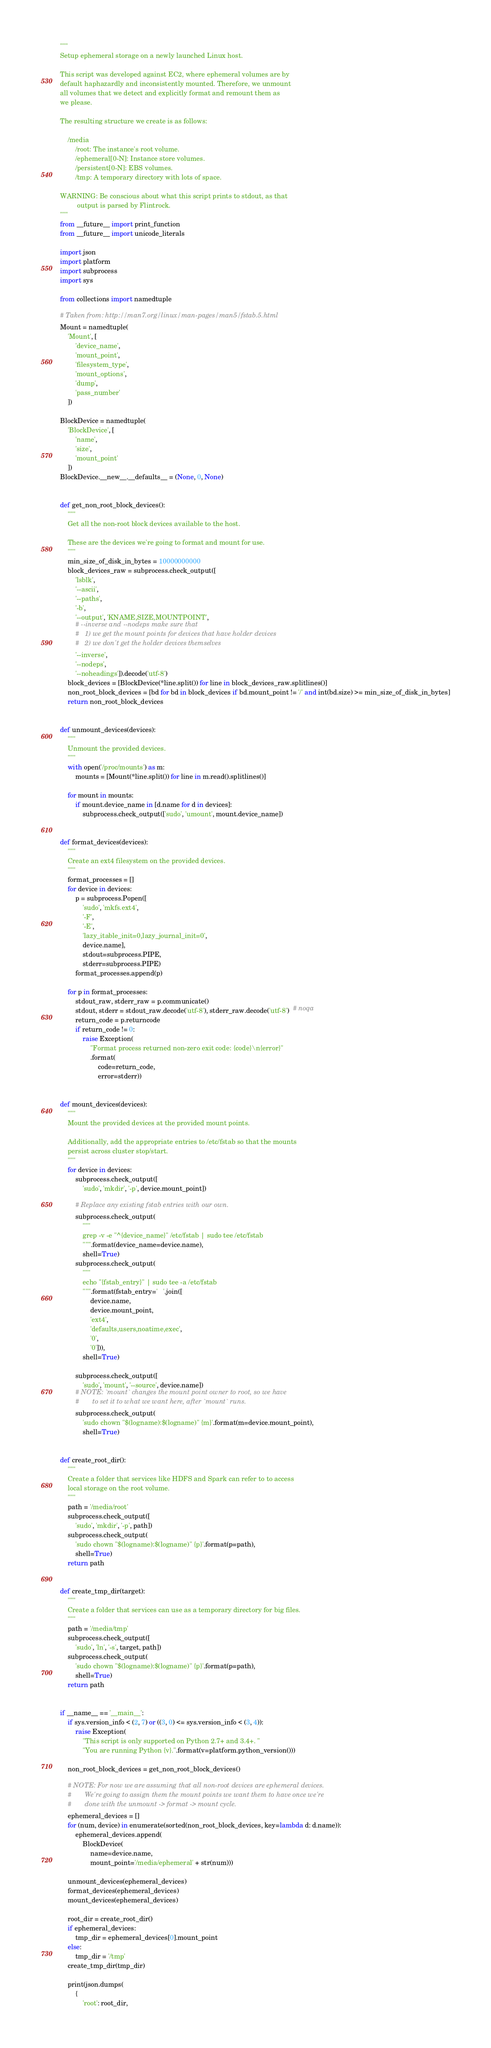Convert code to text. <code><loc_0><loc_0><loc_500><loc_500><_Python_>"""
Setup ephemeral storage on a newly launched Linux host.

This script was developed against EC2, where ephemeral volumes are by
default haphazardly and inconsistently mounted. Therefore, we unmount
all volumes that we detect and explicitly format and remount them as
we please.

The resulting structure we create is as follows:

    /media
        /root: The instance's root volume.
        /ephemeral[0-N]: Instance store volumes.
        /persistent[0-N]: EBS volumes.
        /tmp: A temporary directory with lots of space.

WARNING: Be conscious about what this script prints to stdout, as that
         output is parsed by Flintrock.
"""
from __future__ import print_function
from __future__ import unicode_literals

import json
import platform
import subprocess
import sys

from collections import namedtuple

# Taken from: http://man7.org/linux/man-pages/man5/fstab.5.html
Mount = namedtuple(
    'Mount', [
        'device_name',
        'mount_point',
        'filesystem_type',
        'mount_options',
        'dump',
        'pass_number'
    ])

BlockDevice = namedtuple(
    'BlockDevice', [
        'name',
        'size',
        'mount_point'
    ])
BlockDevice.__new__.__defaults__ = (None, 0, None)


def get_non_root_block_devices():
    """
    Get all the non-root block devices available to the host.

    These are the devices we're going to format and mount for use.
    """
    min_size_of_disk_in_bytes = 10000000000
    block_devices_raw = subprocess.check_output([
        'lsblk',
        '--ascii',
        '--paths',
        '-b',
        '--output', 'KNAME,SIZE,MOUNTPOINT',
        # --inverse and --nodeps make sure that
        #   1) we get the mount points for devices that have holder devices
        #   2) we don't get the holder devices themselves
        '--inverse',
        '--nodeps',
        '--noheadings']).decode('utf-8')
    block_devices = [BlockDevice(*line.split()) for line in block_devices_raw.splitlines()]
    non_root_block_devices = [bd for bd in block_devices if bd.mount_point != '/' and int(bd.size) >= min_size_of_disk_in_bytes]
    return non_root_block_devices


def unmount_devices(devices):
    """
    Unmount the provided devices.
    """
    with open('/proc/mounts') as m:
        mounts = [Mount(*line.split()) for line in m.read().splitlines()]

    for mount in mounts:
        if mount.device_name in [d.name for d in devices]:
            subprocess.check_output(['sudo', 'umount', mount.device_name])


def format_devices(devices):
    """
    Create an ext4 filesystem on the provided devices.
    """
    format_processes = []
    for device in devices:
        p = subprocess.Popen([
            'sudo', 'mkfs.ext4',
            '-F',
            '-E',
            'lazy_itable_init=0,lazy_journal_init=0',
            device.name],
            stdout=subprocess.PIPE,
            stderr=subprocess.PIPE)
        format_processes.append(p)

    for p in format_processes:
        stdout_raw, stderr_raw = p.communicate()
        stdout, stderr = stdout_raw.decode('utf-8'), stderr_raw.decode('utf-8')  # noqa
        return_code = p.returncode
        if return_code != 0:
            raise Exception(
                "Format process returned non-zero exit code: {code}\n{error}"
                .format(
                    code=return_code,
                    error=stderr))


def mount_devices(devices):
    """
    Mount the provided devices at the provided mount points.

    Additionally, add the appropriate entries to /etc/fstab so that the mounts
    persist across cluster stop/start.
    """
    for device in devices:
        subprocess.check_output([
            'sudo', 'mkdir', '-p', device.mount_point])

        # Replace any existing fstab entries with our own.
        subprocess.check_output(
            """
            grep -v -e "^{device_name}" /etc/fstab | sudo tee /etc/fstab
            """.format(device_name=device.name),
            shell=True)
        subprocess.check_output(
            """
            echo "{fstab_entry}" | sudo tee -a /etc/fstab
            """.format(fstab_entry='   '.join([
                device.name,
                device.mount_point,
                'ext4',
                'defaults,users,noatime,exec',
                '0',
                '0'])),
            shell=True)

        subprocess.check_output([
            'sudo', 'mount', '--source', device.name])
        # NOTE: `mount` changes the mount point owner to root, so we have
        #       to set it to what we want here, after `mount` runs.
        subprocess.check_output(
            'sudo chown "$(logname):$(logname)" {m}'.format(m=device.mount_point),
            shell=True)


def create_root_dir():
    """
    Create a folder that services like HDFS and Spark can refer to to access
    local storage on the root volume.
    """
    path = '/media/root'
    subprocess.check_output([
        'sudo', 'mkdir', '-p', path])
    subprocess.check_output(
        'sudo chown "$(logname):$(logname)" {p}'.format(p=path),
        shell=True)
    return path


def create_tmp_dir(target):
    """
    Create a folder that services can use as a temporary directory for big files.
    """
    path = '/media/tmp'
    subprocess.check_output([
        'sudo', 'ln', '-s', target, path])
    subprocess.check_output(
        'sudo chown "$(logname):$(logname)" {p}'.format(p=path),
        shell=True)
    return path


if __name__ == '__main__':
    if sys.version_info < (2, 7) or ((3, 0) <= sys.version_info < (3, 4)):
        raise Exception(
            "This script is only supported on Python 2.7+ and 3.4+. "
            "You are running Python {v}.".format(v=platform.python_version()))

    non_root_block_devices = get_non_root_block_devices()

    # NOTE: For now we are assuming that all non-root devices are ephemeral devices.
    #       We're going to assign them the mount points we want them to have once we're
    #       done with the unmount -> format -> mount cycle.
    ephemeral_devices = []
    for (num, device) in enumerate(sorted(non_root_block_devices, key=lambda d: d.name)):
        ephemeral_devices.append(
            BlockDevice(
                name=device.name,
                mount_point='/media/ephemeral' + str(num)))

    unmount_devices(ephemeral_devices)
    format_devices(ephemeral_devices)
    mount_devices(ephemeral_devices)

    root_dir = create_root_dir()
    if ephemeral_devices:
        tmp_dir = ephemeral_devices[0].mount_point
    else:
        tmp_dir = '/tmp'
    create_tmp_dir(tmp_dir)

    print(json.dumps(
        {
            'root': root_dir,</code> 